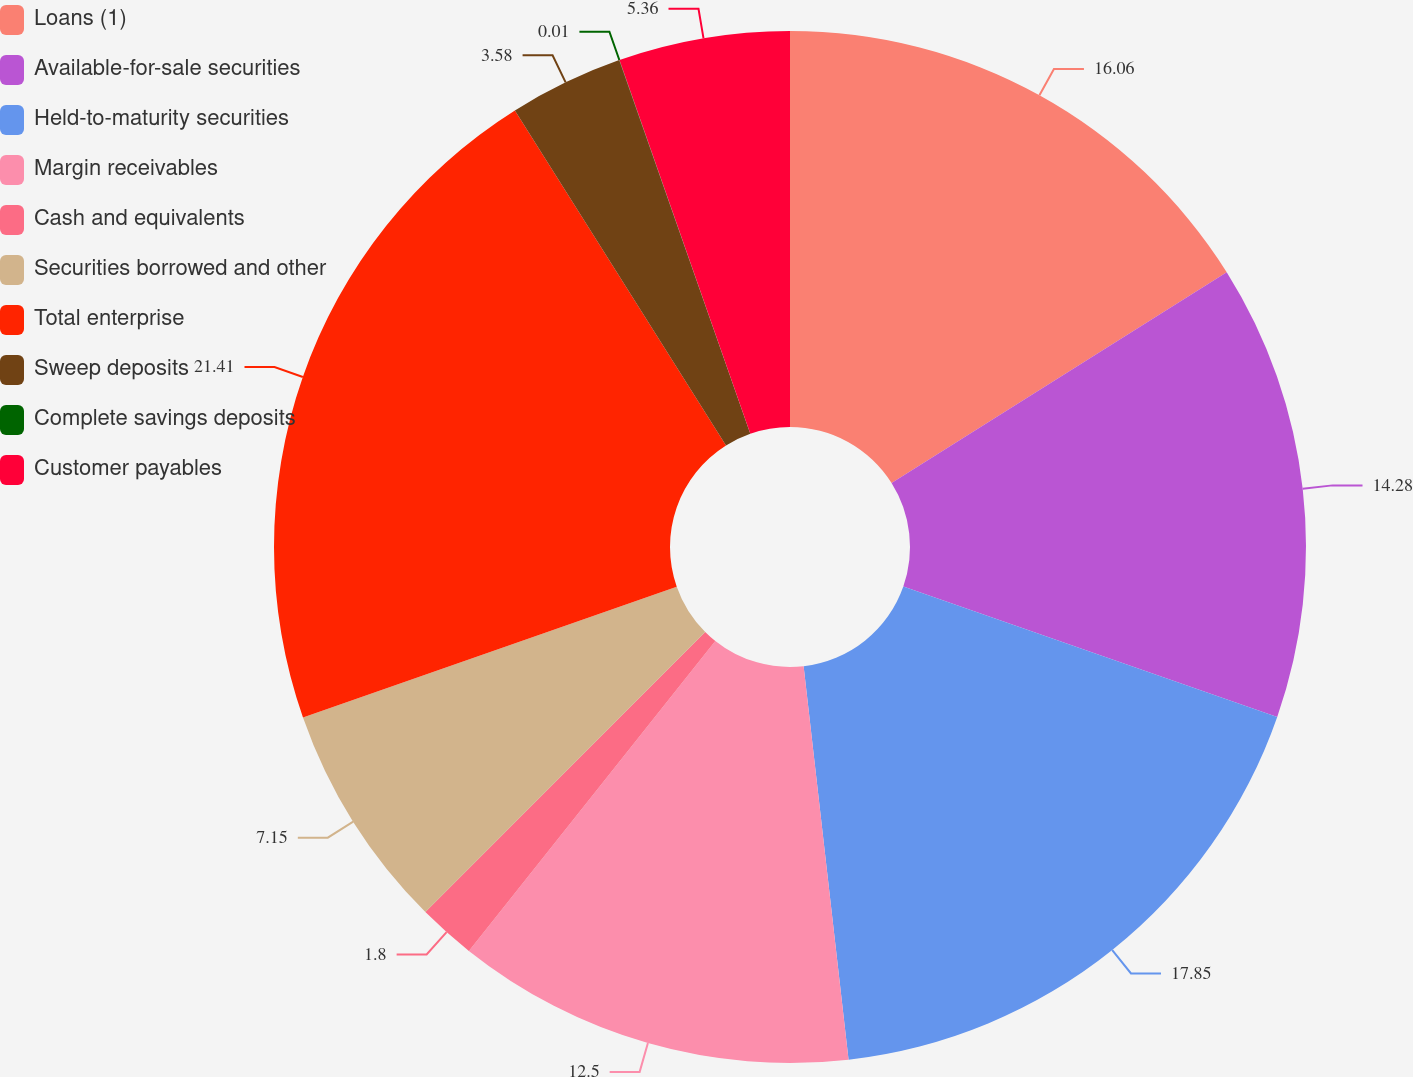Convert chart. <chart><loc_0><loc_0><loc_500><loc_500><pie_chart><fcel>Loans (1)<fcel>Available-for-sale securities<fcel>Held-to-maturity securities<fcel>Margin receivables<fcel>Cash and equivalents<fcel>Securities borrowed and other<fcel>Total enterprise<fcel>Sweep deposits<fcel>Complete savings deposits<fcel>Customer payables<nl><fcel>16.06%<fcel>14.28%<fcel>17.85%<fcel>12.5%<fcel>1.8%<fcel>7.15%<fcel>21.41%<fcel>3.58%<fcel>0.01%<fcel>5.36%<nl></chart> 